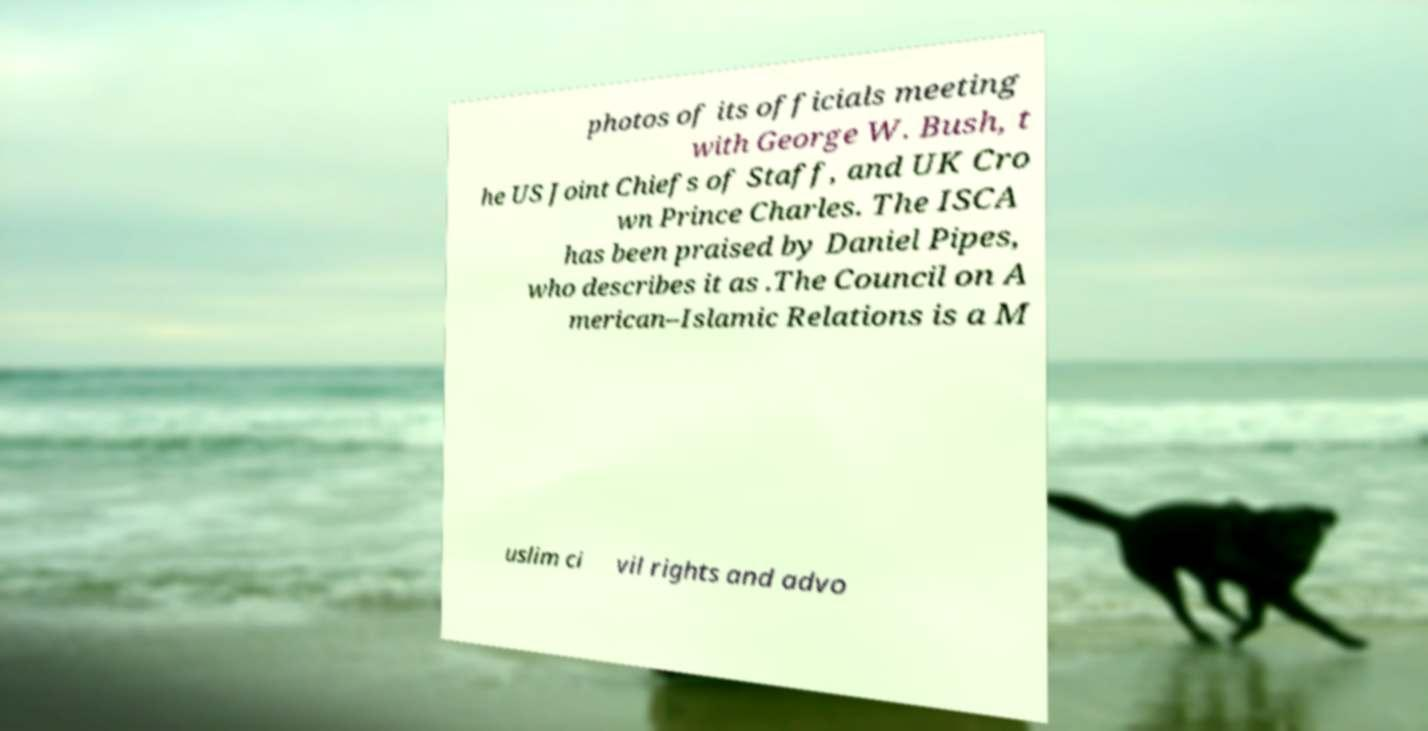I need the written content from this picture converted into text. Can you do that? photos of its officials meeting with George W. Bush, t he US Joint Chiefs of Staff, and UK Cro wn Prince Charles. The ISCA has been praised by Daniel Pipes, who describes it as .The Council on A merican–Islamic Relations is a M uslim ci vil rights and advo 